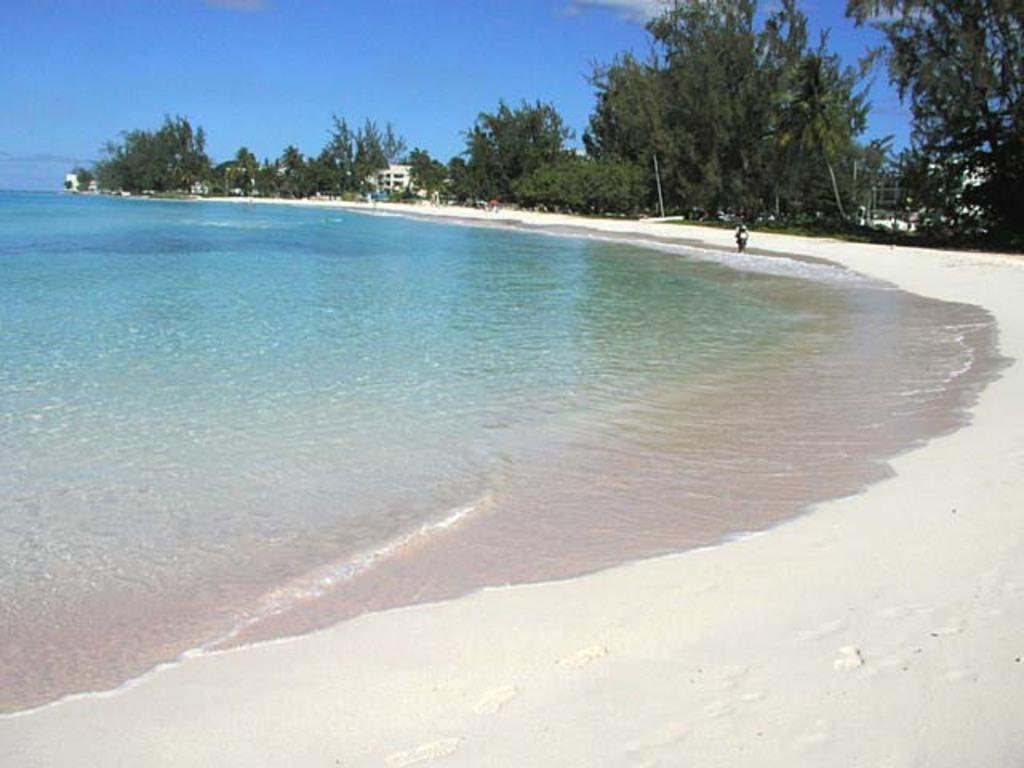What type of natural environment is depicted in the image? There is a beach in the image. What can be seen surrounding the beach? There are trees and houses around the beach. What is the person in the image doing? There is a person moving on the sand in front of the beach. What type of relation does the balloon have with the beach in the image? There is no balloon present in the image, so it cannot have any relation with the beach. 